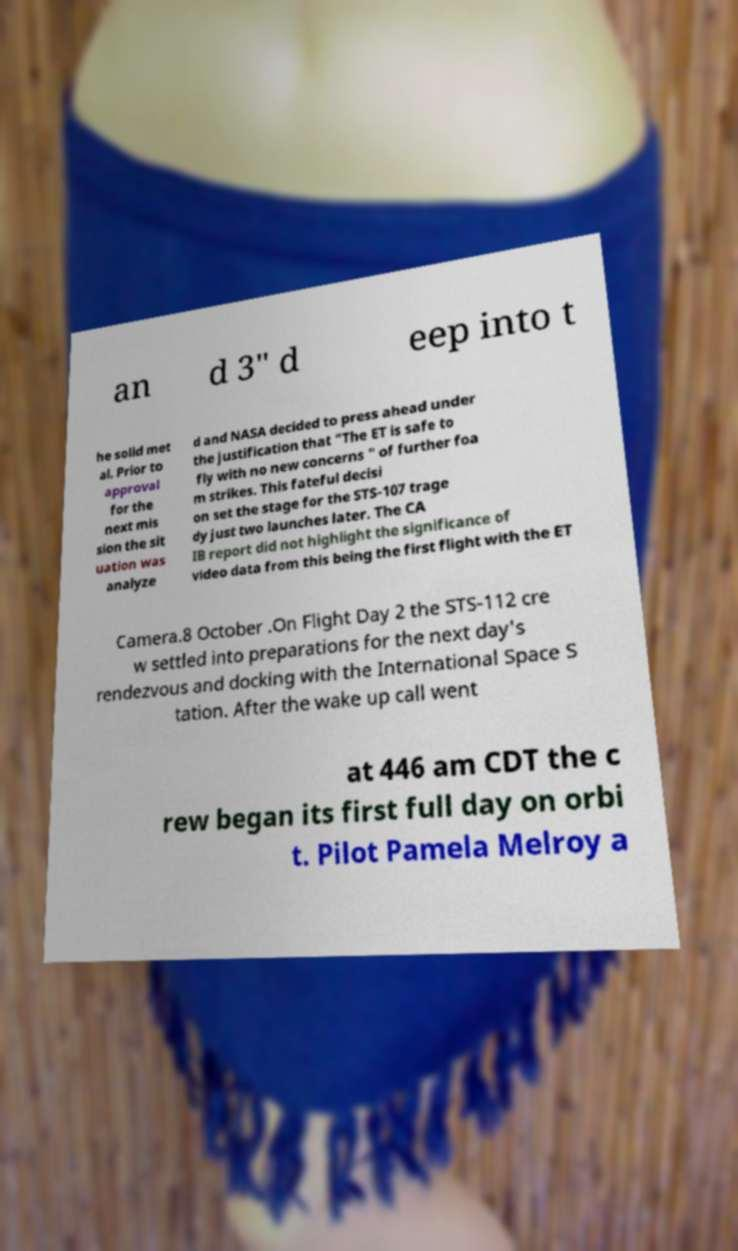There's text embedded in this image that I need extracted. Can you transcribe it verbatim? an d 3" d eep into t he solid met al. Prior to approval for the next mis sion the sit uation was analyze d and NASA decided to press ahead under the justification that "The ET is safe to fly with no new concerns " of further foa m strikes. This fateful decisi on set the stage for the STS-107 trage dy just two launches later. The CA IB report did not highlight the significance of video data from this being the first flight with the ET Camera.8 October .On Flight Day 2 the STS-112 cre w settled into preparations for the next day's rendezvous and docking with the International Space S tation. After the wake up call went at 446 am CDT the c rew began its first full day on orbi t. Pilot Pamela Melroy a 